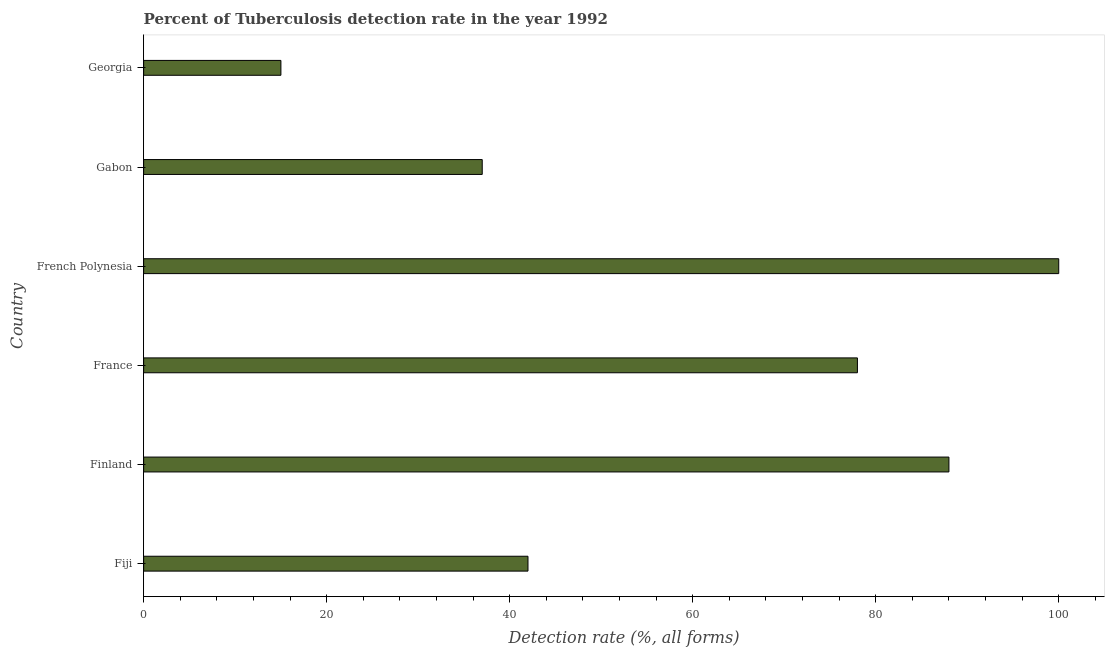Does the graph contain grids?
Your answer should be very brief. No. What is the title of the graph?
Give a very brief answer. Percent of Tuberculosis detection rate in the year 1992. What is the label or title of the X-axis?
Ensure brevity in your answer.  Detection rate (%, all forms). What is the label or title of the Y-axis?
Make the answer very short. Country. What is the detection rate of tuberculosis in French Polynesia?
Keep it short and to the point. 100. In which country was the detection rate of tuberculosis maximum?
Your response must be concise. French Polynesia. In which country was the detection rate of tuberculosis minimum?
Your answer should be very brief. Georgia. What is the sum of the detection rate of tuberculosis?
Your response must be concise. 360. What is the ratio of the detection rate of tuberculosis in Fiji to that in Georgia?
Provide a short and direct response. 2.8. Is the difference between the detection rate of tuberculosis in Fiji and France greater than the difference between any two countries?
Provide a short and direct response. No. What is the difference between the highest and the second highest detection rate of tuberculosis?
Keep it short and to the point. 12. Is the sum of the detection rate of tuberculosis in French Polynesia and Gabon greater than the maximum detection rate of tuberculosis across all countries?
Your answer should be compact. Yes. What is the difference between the highest and the lowest detection rate of tuberculosis?
Offer a very short reply. 85. How many countries are there in the graph?
Keep it short and to the point. 6. Are the values on the major ticks of X-axis written in scientific E-notation?
Keep it short and to the point. No. What is the Detection rate (%, all forms) in Fiji?
Provide a short and direct response. 42. What is the Detection rate (%, all forms) of Finland?
Offer a terse response. 88. What is the Detection rate (%, all forms) in France?
Provide a short and direct response. 78. What is the Detection rate (%, all forms) in Georgia?
Offer a very short reply. 15. What is the difference between the Detection rate (%, all forms) in Fiji and Finland?
Provide a short and direct response. -46. What is the difference between the Detection rate (%, all forms) in Fiji and France?
Your answer should be very brief. -36. What is the difference between the Detection rate (%, all forms) in Fiji and French Polynesia?
Provide a succinct answer. -58. What is the difference between the Detection rate (%, all forms) in Fiji and Gabon?
Offer a very short reply. 5. What is the difference between the Detection rate (%, all forms) in Finland and France?
Your response must be concise. 10. What is the difference between the Detection rate (%, all forms) in Finland and Gabon?
Give a very brief answer. 51. What is the difference between the Detection rate (%, all forms) in France and Gabon?
Your response must be concise. 41. What is the difference between the Detection rate (%, all forms) in French Polynesia and Gabon?
Provide a short and direct response. 63. What is the difference between the Detection rate (%, all forms) in French Polynesia and Georgia?
Offer a terse response. 85. What is the ratio of the Detection rate (%, all forms) in Fiji to that in Finland?
Your answer should be very brief. 0.48. What is the ratio of the Detection rate (%, all forms) in Fiji to that in France?
Your answer should be compact. 0.54. What is the ratio of the Detection rate (%, all forms) in Fiji to that in French Polynesia?
Provide a short and direct response. 0.42. What is the ratio of the Detection rate (%, all forms) in Fiji to that in Gabon?
Offer a terse response. 1.14. What is the ratio of the Detection rate (%, all forms) in Fiji to that in Georgia?
Offer a terse response. 2.8. What is the ratio of the Detection rate (%, all forms) in Finland to that in France?
Your answer should be compact. 1.13. What is the ratio of the Detection rate (%, all forms) in Finland to that in Gabon?
Make the answer very short. 2.38. What is the ratio of the Detection rate (%, all forms) in Finland to that in Georgia?
Ensure brevity in your answer.  5.87. What is the ratio of the Detection rate (%, all forms) in France to that in French Polynesia?
Make the answer very short. 0.78. What is the ratio of the Detection rate (%, all forms) in France to that in Gabon?
Make the answer very short. 2.11. What is the ratio of the Detection rate (%, all forms) in France to that in Georgia?
Ensure brevity in your answer.  5.2. What is the ratio of the Detection rate (%, all forms) in French Polynesia to that in Gabon?
Ensure brevity in your answer.  2.7. What is the ratio of the Detection rate (%, all forms) in French Polynesia to that in Georgia?
Provide a succinct answer. 6.67. What is the ratio of the Detection rate (%, all forms) in Gabon to that in Georgia?
Keep it short and to the point. 2.47. 